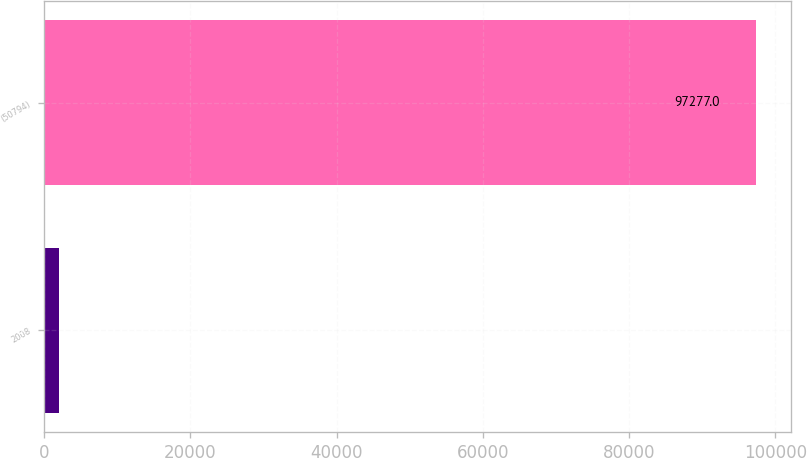Convert chart to OTSL. <chart><loc_0><loc_0><loc_500><loc_500><bar_chart><fcel>2008<fcel>(50794)<nl><fcel>2006<fcel>97277<nl></chart> 